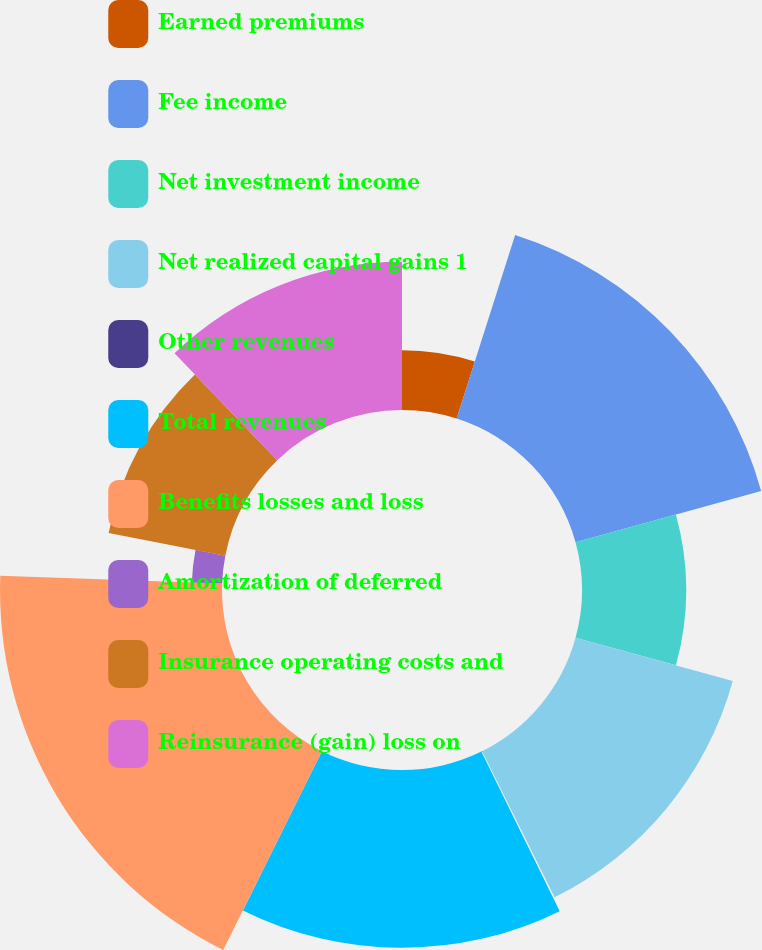Convert chart to OTSL. <chart><loc_0><loc_0><loc_500><loc_500><pie_chart><fcel>Earned premiums<fcel>Fee income<fcel>Net investment income<fcel>Net realized capital gains 1<fcel>Other revenues<fcel>Total revenues<fcel>Benefits losses and loss<fcel>Amortization of deferred<fcel>Insurance operating costs and<fcel>Reinsurance (gain) loss on<nl><fcel>4.91%<fcel>15.81%<fcel>8.55%<fcel>13.39%<fcel>0.07%<fcel>14.6%<fcel>18.23%<fcel>2.49%<fcel>9.76%<fcel>12.18%<nl></chart> 